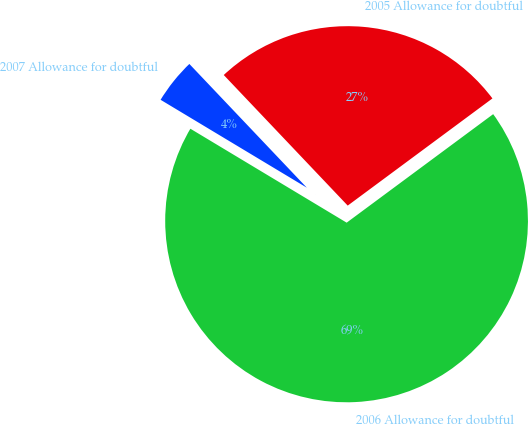<chart> <loc_0><loc_0><loc_500><loc_500><pie_chart><fcel>2007 Allowance for doubtful<fcel>2006 Allowance for doubtful<fcel>2005 Allowance for doubtful<nl><fcel>4.3%<fcel>68.76%<fcel>26.94%<nl></chart> 